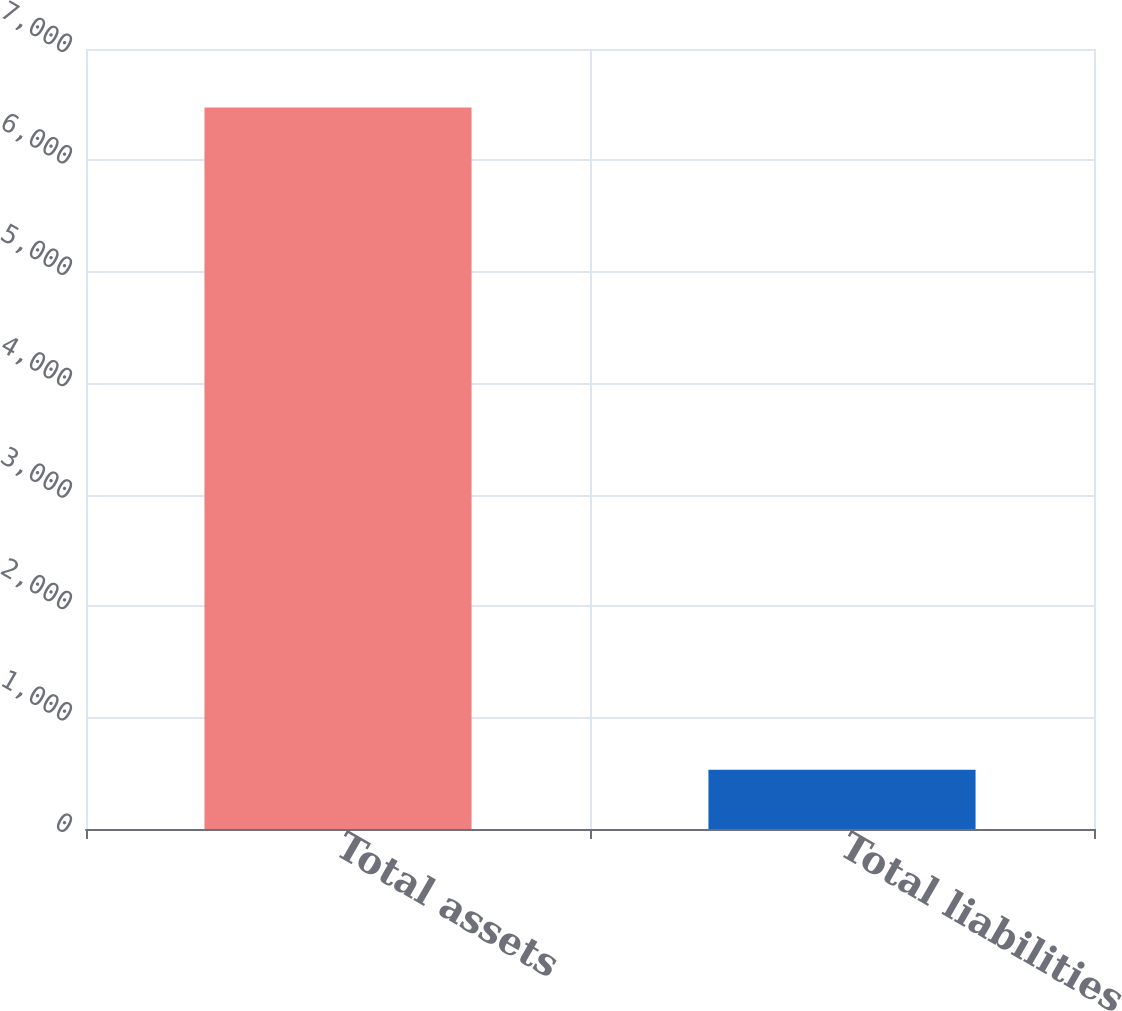<chart> <loc_0><loc_0><loc_500><loc_500><bar_chart><fcel>Total assets<fcel>Total liabilities<nl><fcel>6475<fcel>531<nl></chart> 